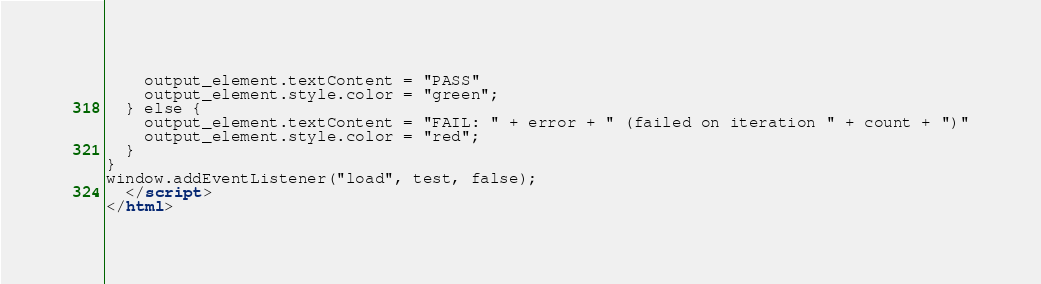<code> <loc_0><loc_0><loc_500><loc_500><_HTML_>    output_element.textContent = "PASS"
    output_element.style.color = "green";
  } else {
    output_element.textContent = "FAIL: " + error + " (failed on iteration " + count + ")"
    output_element.style.color = "red";
  }
}
window.addEventListener("load", test, false);
  </script>
</html></code> 